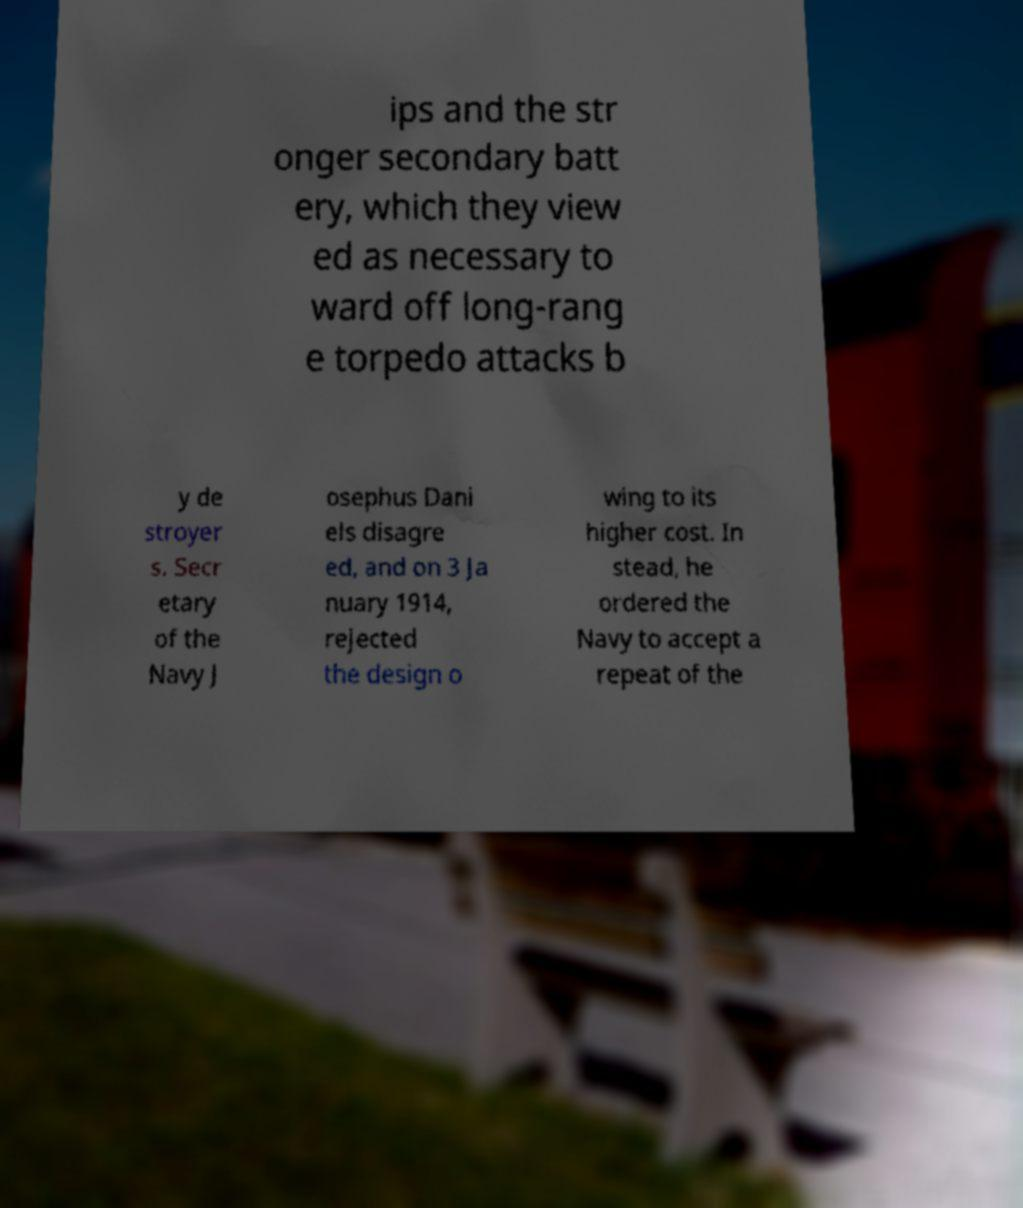Could you assist in decoding the text presented in this image and type it out clearly? ips and the str onger secondary batt ery, which they view ed as necessary to ward off long-rang e torpedo attacks b y de stroyer s. Secr etary of the Navy J osephus Dani els disagre ed, and on 3 Ja nuary 1914, rejected the design o wing to its higher cost. In stead, he ordered the Navy to accept a repeat of the 